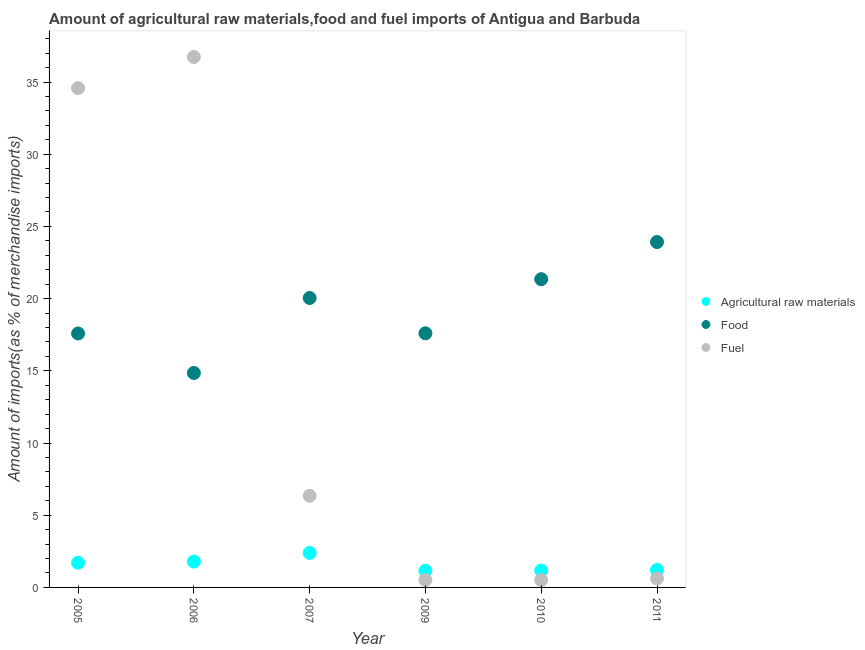How many different coloured dotlines are there?
Ensure brevity in your answer.  3. Is the number of dotlines equal to the number of legend labels?
Make the answer very short. Yes. What is the percentage of raw materials imports in 2006?
Offer a very short reply. 1.79. Across all years, what is the maximum percentage of raw materials imports?
Keep it short and to the point. 2.39. Across all years, what is the minimum percentage of fuel imports?
Your answer should be compact. 0.51. What is the total percentage of food imports in the graph?
Provide a succinct answer. 115.35. What is the difference between the percentage of food imports in 2007 and that in 2010?
Your answer should be very brief. -1.3. What is the difference between the percentage of raw materials imports in 2007 and the percentage of fuel imports in 2010?
Provide a succinct answer. 1.88. What is the average percentage of food imports per year?
Make the answer very short. 19.22. In the year 2005, what is the difference between the percentage of food imports and percentage of fuel imports?
Your answer should be compact. -16.99. In how many years, is the percentage of fuel imports greater than 28 %?
Give a very brief answer. 2. What is the ratio of the percentage of raw materials imports in 2005 to that in 2009?
Make the answer very short. 1.49. Is the percentage of fuel imports in 2010 less than that in 2011?
Provide a short and direct response. Yes. Is the difference between the percentage of raw materials imports in 2006 and 2007 greater than the difference between the percentage of fuel imports in 2006 and 2007?
Provide a succinct answer. No. What is the difference between the highest and the second highest percentage of food imports?
Provide a short and direct response. 2.57. What is the difference between the highest and the lowest percentage of fuel imports?
Make the answer very short. 36.22. In how many years, is the percentage of fuel imports greater than the average percentage of fuel imports taken over all years?
Your answer should be compact. 2. Is it the case that in every year, the sum of the percentage of raw materials imports and percentage of food imports is greater than the percentage of fuel imports?
Your answer should be very brief. No. Does the percentage of raw materials imports monotonically increase over the years?
Your answer should be compact. No. Is the percentage of raw materials imports strictly greater than the percentage of fuel imports over the years?
Keep it short and to the point. No. Is the percentage of raw materials imports strictly less than the percentage of fuel imports over the years?
Give a very brief answer. No. How many years are there in the graph?
Ensure brevity in your answer.  6. What is the difference between two consecutive major ticks on the Y-axis?
Offer a terse response. 5. Are the values on the major ticks of Y-axis written in scientific E-notation?
Provide a succinct answer. No. Does the graph contain grids?
Ensure brevity in your answer.  No. Where does the legend appear in the graph?
Ensure brevity in your answer.  Center right. How many legend labels are there?
Ensure brevity in your answer.  3. How are the legend labels stacked?
Ensure brevity in your answer.  Vertical. What is the title of the graph?
Provide a succinct answer. Amount of agricultural raw materials,food and fuel imports of Antigua and Barbuda. Does "Fuel" appear as one of the legend labels in the graph?
Ensure brevity in your answer.  Yes. What is the label or title of the Y-axis?
Keep it short and to the point. Amount of imports(as % of merchandise imports). What is the Amount of imports(as % of merchandise imports) of Agricultural raw materials in 2005?
Offer a terse response. 1.71. What is the Amount of imports(as % of merchandise imports) in Food in 2005?
Keep it short and to the point. 17.59. What is the Amount of imports(as % of merchandise imports) of Fuel in 2005?
Offer a very short reply. 34.58. What is the Amount of imports(as % of merchandise imports) in Agricultural raw materials in 2006?
Provide a short and direct response. 1.79. What is the Amount of imports(as % of merchandise imports) in Food in 2006?
Ensure brevity in your answer.  14.85. What is the Amount of imports(as % of merchandise imports) in Fuel in 2006?
Provide a succinct answer. 36.73. What is the Amount of imports(as % of merchandise imports) in Agricultural raw materials in 2007?
Your response must be concise. 2.39. What is the Amount of imports(as % of merchandise imports) of Food in 2007?
Give a very brief answer. 20.04. What is the Amount of imports(as % of merchandise imports) of Fuel in 2007?
Give a very brief answer. 6.35. What is the Amount of imports(as % of merchandise imports) of Agricultural raw materials in 2009?
Offer a very short reply. 1.15. What is the Amount of imports(as % of merchandise imports) of Food in 2009?
Offer a very short reply. 17.6. What is the Amount of imports(as % of merchandise imports) in Fuel in 2009?
Your answer should be very brief. 0.52. What is the Amount of imports(as % of merchandise imports) in Agricultural raw materials in 2010?
Your answer should be very brief. 1.17. What is the Amount of imports(as % of merchandise imports) of Food in 2010?
Provide a succinct answer. 21.35. What is the Amount of imports(as % of merchandise imports) of Fuel in 2010?
Your answer should be very brief. 0.51. What is the Amount of imports(as % of merchandise imports) in Agricultural raw materials in 2011?
Your response must be concise. 1.21. What is the Amount of imports(as % of merchandise imports) in Food in 2011?
Provide a succinct answer. 23.92. What is the Amount of imports(as % of merchandise imports) of Fuel in 2011?
Provide a succinct answer. 0.62. Across all years, what is the maximum Amount of imports(as % of merchandise imports) of Agricultural raw materials?
Your answer should be compact. 2.39. Across all years, what is the maximum Amount of imports(as % of merchandise imports) in Food?
Keep it short and to the point. 23.92. Across all years, what is the maximum Amount of imports(as % of merchandise imports) in Fuel?
Provide a succinct answer. 36.73. Across all years, what is the minimum Amount of imports(as % of merchandise imports) in Agricultural raw materials?
Your response must be concise. 1.15. Across all years, what is the minimum Amount of imports(as % of merchandise imports) of Food?
Ensure brevity in your answer.  14.85. Across all years, what is the minimum Amount of imports(as % of merchandise imports) in Fuel?
Provide a succinct answer. 0.51. What is the total Amount of imports(as % of merchandise imports) of Agricultural raw materials in the graph?
Provide a succinct answer. 9.42. What is the total Amount of imports(as % of merchandise imports) of Food in the graph?
Ensure brevity in your answer.  115.35. What is the total Amount of imports(as % of merchandise imports) in Fuel in the graph?
Your response must be concise. 79.31. What is the difference between the Amount of imports(as % of merchandise imports) in Agricultural raw materials in 2005 and that in 2006?
Give a very brief answer. -0.08. What is the difference between the Amount of imports(as % of merchandise imports) in Food in 2005 and that in 2006?
Provide a succinct answer. 2.74. What is the difference between the Amount of imports(as % of merchandise imports) in Fuel in 2005 and that in 2006?
Offer a very short reply. -2.16. What is the difference between the Amount of imports(as % of merchandise imports) in Agricultural raw materials in 2005 and that in 2007?
Your answer should be very brief. -0.68. What is the difference between the Amount of imports(as % of merchandise imports) of Food in 2005 and that in 2007?
Give a very brief answer. -2.46. What is the difference between the Amount of imports(as % of merchandise imports) of Fuel in 2005 and that in 2007?
Ensure brevity in your answer.  28.23. What is the difference between the Amount of imports(as % of merchandise imports) in Agricultural raw materials in 2005 and that in 2009?
Provide a succinct answer. 0.56. What is the difference between the Amount of imports(as % of merchandise imports) of Food in 2005 and that in 2009?
Offer a terse response. -0.01. What is the difference between the Amount of imports(as % of merchandise imports) in Fuel in 2005 and that in 2009?
Give a very brief answer. 34.06. What is the difference between the Amount of imports(as % of merchandise imports) in Agricultural raw materials in 2005 and that in 2010?
Give a very brief answer. 0.54. What is the difference between the Amount of imports(as % of merchandise imports) in Food in 2005 and that in 2010?
Provide a short and direct response. -3.76. What is the difference between the Amount of imports(as % of merchandise imports) in Fuel in 2005 and that in 2010?
Provide a succinct answer. 34.06. What is the difference between the Amount of imports(as % of merchandise imports) of Agricultural raw materials in 2005 and that in 2011?
Your answer should be very brief. 0.5. What is the difference between the Amount of imports(as % of merchandise imports) in Food in 2005 and that in 2011?
Provide a short and direct response. -6.33. What is the difference between the Amount of imports(as % of merchandise imports) of Fuel in 2005 and that in 2011?
Offer a terse response. 33.95. What is the difference between the Amount of imports(as % of merchandise imports) of Agricultural raw materials in 2006 and that in 2007?
Give a very brief answer. -0.6. What is the difference between the Amount of imports(as % of merchandise imports) of Food in 2006 and that in 2007?
Provide a succinct answer. -5.19. What is the difference between the Amount of imports(as % of merchandise imports) of Fuel in 2006 and that in 2007?
Offer a terse response. 30.39. What is the difference between the Amount of imports(as % of merchandise imports) in Agricultural raw materials in 2006 and that in 2009?
Provide a short and direct response. 0.64. What is the difference between the Amount of imports(as % of merchandise imports) of Food in 2006 and that in 2009?
Ensure brevity in your answer.  -2.75. What is the difference between the Amount of imports(as % of merchandise imports) of Fuel in 2006 and that in 2009?
Provide a succinct answer. 36.22. What is the difference between the Amount of imports(as % of merchandise imports) of Agricultural raw materials in 2006 and that in 2010?
Your answer should be compact. 0.62. What is the difference between the Amount of imports(as % of merchandise imports) of Food in 2006 and that in 2010?
Offer a very short reply. -6.49. What is the difference between the Amount of imports(as % of merchandise imports) in Fuel in 2006 and that in 2010?
Offer a terse response. 36.22. What is the difference between the Amount of imports(as % of merchandise imports) in Agricultural raw materials in 2006 and that in 2011?
Make the answer very short. 0.58. What is the difference between the Amount of imports(as % of merchandise imports) of Food in 2006 and that in 2011?
Your answer should be compact. -9.07. What is the difference between the Amount of imports(as % of merchandise imports) of Fuel in 2006 and that in 2011?
Offer a very short reply. 36.11. What is the difference between the Amount of imports(as % of merchandise imports) in Agricultural raw materials in 2007 and that in 2009?
Your answer should be very brief. 1.24. What is the difference between the Amount of imports(as % of merchandise imports) of Food in 2007 and that in 2009?
Offer a very short reply. 2.44. What is the difference between the Amount of imports(as % of merchandise imports) in Fuel in 2007 and that in 2009?
Make the answer very short. 5.83. What is the difference between the Amount of imports(as % of merchandise imports) in Agricultural raw materials in 2007 and that in 2010?
Keep it short and to the point. 1.22. What is the difference between the Amount of imports(as % of merchandise imports) of Food in 2007 and that in 2010?
Give a very brief answer. -1.3. What is the difference between the Amount of imports(as % of merchandise imports) in Fuel in 2007 and that in 2010?
Provide a short and direct response. 5.84. What is the difference between the Amount of imports(as % of merchandise imports) in Agricultural raw materials in 2007 and that in 2011?
Your answer should be compact. 1.18. What is the difference between the Amount of imports(as % of merchandise imports) of Food in 2007 and that in 2011?
Your answer should be compact. -3.87. What is the difference between the Amount of imports(as % of merchandise imports) in Fuel in 2007 and that in 2011?
Keep it short and to the point. 5.72. What is the difference between the Amount of imports(as % of merchandise imports) in Agricultural raw materials in 2009 and that in 2010?
Your response must be concise. -0.02. What is the difference between the Amount of imports(as % of merchandise imports) in Food in 2009 and that in 2010?
Ensure brevity in your answer.  -3.75. What is the difference between the Amount of imports(as % of merchandise imports) of Fuel in 2009 and that in 2010?
Provide a succinct answer. 0.01. What is the difference between the Amount of imports(as % of merchandise imports) in Agricultural raw materials in 2009 and that in 2011?
Offer a very short reply. -0.06. What is the difference between the Amount of imports(as % of merchandise imports) in Food in 2009 and that in 2011?
Your answer should be very brief. -6.32. What is the difference between the Amount of imports(as % of merchandise imports) in Fuel in 2009 and that in 2011?
Give a very brief answer. -0.1. What is the difference between the Amount of imports(as % of merchandise imports) of Agricultural raw materials in 2010 and that in 2011?
Make the answer very short. -0.04. What is the difference between the Amount of imports(as % of merchandise imports) in Food in 2010 and that in 2011?
Give a very brief answer. -2.57. What is the difference between the Amount of imports(as % of merchandise imports) in Fuel in 2010 and that in 2011?
Provide a succinct answer. -0.11. What is the difference between the Amount of imports(as % of merchandise imports) of Agricultural raw materials in 2005 and the Amount of imports(as % of merchandise imports) of Food in 2006?
Your answer should be very brief. -13.14. What is the difference between the Amount of imports(as % of merchandise imports) in Agricultural raw materials in 2005 and the Amount of imports(as % of merchandise imports) in Fuel in 2006?
Offer a terse response. -35.02. What is the difference between the Amount of imports(as % of merchandise imports) of Food in 2005 and the Amount of imports(as % of merchandise imports) of Fuel in 2006?
Your response must be concise. -19.15. What is the difference between the Amount of imports(as % of merchandise imports) in Agricultural raw materials in 2005 and the Amount of imports(as % of merchandise imports) in Food in 2007?
Keep it short and to the point. -18.33. What is the difference between the Amount of imports(as % of merchandise imports) in Agricultural raw materials in 2005 and the Amount of imports(as % of merchandise imports) in Fuel in 2007?
Give a very brief answer. -4.64. What is the difference between the Amount of imports(as % of merchandise imports) in Food in 2005 and the Amount of imports(as % of merchandise imports) in Fuel in 2007?
Keep it short and to the point. 11.24. What is the difference between the Amount of imports(as % of merchandise imports) of Agricultural raw materials in 2005 and the Amount of imports(as % of merchandise imports) of Food in 2009?
Your answer should be compact. -15.89. What is the difference between the Amount of imports(as % of merchandise imports) in Agricultural raw materials in 2005 and the Amount of imports(as % of merchandise imports) in Fuel in 2009?
Give a very brief answer. 1.19. What is the difference between the Amount of imports(as % of merchandise imports) of Food in 2005 and the Amount of imports(as % of merchandise imports) of Fuel in 2009?
Offer a very short reply. 17.07. What is the difference between the Amount of imports(as % of merchandise imports) in Agricultural raw materials in 2005 and the Amount of imports(as % of merchandise imports) in Food in 2010?
Keep it short and to the point. -19.64. What is the difference between the Amount of imports(as % of merchandise imports) of Agricultural raw materials in 2005 and the Amount of imports(as % of merchandise imports) of Fuel in 2010?
Your answer should be compact. 1.2. What is the difference between the Amount of imports(as % of merchandise imports) in Food in 2005 and the Amount of imports(as % of merchandise imports) in Fuel in 2010?
Offer a terse response. 17.08. What is the difference between the Amount of imports(as % of merchandise imports) in Agricultural raw materials in 2005 and the Amount of imports(as % of merchandise imports) in Food in 2011?
Keep it short and to the point. -22.21. What is the difference between the Amount of imports(as % of merchandise imports) in Agricultural raw materials in 2005 and the Amount of imports(as % of merchandise imports) in Fuel in 2011?
Make the answer very short. 1.09. What is the difference between the Amount of imports(as % of merchandise imports) in Food in 2005 and the Amount of imports(as % of merchandise imports) in Fuel in 2011?
Provide a succinct answer. 16.97. What is the difference between the Amount of imports(as % of merchandise imports) in Agricultural raw materials in 2006 and the Amount of imports(as % of merchandise imports) in Food in 2007?
Offer a terse response. -18.25. What is the difference between the Amount of imports(as % of merchandise imports) in Agricultural raw materials in 2006 and the Amount of imports(as % of merchandise imports) in Fuel in 2007?
Provide a succinct answer. -4.55. What is the difference between the Amount of imports(as % of merchandise imports) in Food in 2006 and the Amount of imports(as % of merchandise imports) in Fuel in 2007?
Give a very brief answer. 8.51. What is the difference between the Amount of imports(as % of merchandise imports) of Agricultural raw materials in 2006 and the Amount of imports(as % of merchandise imports) of Food in 2009?
Ensure brevity in your answer.  -15.81. What is the difference between the Amount of imports(as % of merchandise imports) of Agricultural raw materials in 2006 and the Amount of imports(as % of merchandise imports) of Fuel in 2009?
Offer a very short reply. 1.27. What is the difference between the Amount of imports(as % of merchandise imports) of Food in 2006 and the Amount of imports(as % of merchandise imports) of Fuel in 2009?
Provide a short and direct response. 14.33. What is the difference between the Amount of imports(as % of merchandise imports) in Agricultural raw materials in 2006 and the Amount of imports(as % of merchandise imports) in Food in 2010?
Ensure brevity in your answer.  -19.55. What is the difference between the Amount of imports(as % of merchandise imports) in Agricultural raw materials in 2006 and the Amount of imports(as % of merchandise imports) in Fuel in 2010?
Give a very brief answer. 1.28. What is the difference between the Amount of imports(as % of merchandise imports) in Food in 2006 and the Amount of imports(as % of merchandise imports) in Fuel in 2010?
Make the answer very short. 14.34. What is the difference between the Amount of imports(as % of merchandise imports) in Agricultural raw materials in 2006 and the Amount of imports(as % of merchandise imports) in Food in 2011?
Make the answer very short. -22.13. What is the difference between the Amount of imports(as % of merchandise imports) of Agricultural raw materials in 2006 and the Amount of imports(as % of merchandise imports) of Fuel in 2011?
Provide a short and direct response. 1.17. What is the difference between the Amount of imports(as % of merchandise imports) in Food in 2006 and the Amount of imports(as % of merchandise imports) in Fuel in 2011?
Ensure brevity in your answer.  14.23. What is the difference between the Amount of imports(as % of merchandise imports) in Agricultural raw materials in 2007 and the Amount of imports(as % of merchandise imports) in Food in 2009?
Ensure brevity in your answer.  -15.21. What is the difference between the Amount of imports(as % of merchandise imports) in Agricultural raw materials in 2007 and the Amount of imports(as % of merchandise imports) in Fuel in 2009?
Offer a very short reply. 1.87. What is the difference between the Amount of imports(as % of merchandise imports) in Food in 2007 and the Amount of imports(as % of merchandise imports) in Fuel in 2009?
Make the answer very short. 19.53. What is the difference between the Amount of imports(as % of merchandise imports) of Agricultural raw materials in 2007 and the Amount of imports(as % of merchandise imports) of Food in 2010?
Your answer should be very brief. -18.96. What is the difference between the Amount of imports(as % of merchandise imports) in Agricultural raw materials in 2007 and the Amount of imports(as % of merchandise imports) in Fuel in 2010?
Offer a very short reply. 1.88. What is the difference between the Amount of imports(as % of merchandise imports) in Food in 2007 and the Amount of imports(as % of merchandise imports) in Fuel in 2010?
Offer a terse response. 19.53. What is the difference between the Amount of imports(as % of merchandise imports) in Agricultural raw materials in 2007 and the Amount of imports(as % of merchandise imports) in Food in 2011?
Offer a very short reply. -21.53. What is the difference between the Amount of imports(as % of merchandise imports) in Agricultural raw materials in 2007 and the Amount of imports(as % of merchandise imports) in Fuel in 2011?
Provide a short and direct response. 1.77. What is the difference between the Amount of imports(as % of merchandise imports) in Food in 2007 and the Amount of imports(as % of merchandise imports) in Fuel in 2011?
Ensure brevity in your answer.  19.42. What is the difference between the Amount of imports(as % of merchandise imports) of Agricultural raw materials in 2009 and the Amount of imports(as % of merchandise imports) of Food in 2010?
Provide a succinct answer. -20.19. What is the difference between the Amount of imports(as % of merchandise imports) of Agricultural raw materials in 2009 and the Amount of imports(as % of merchandise imports) of Fuel in 2010?
Keep it short and to the point. 0.64. What is the difference between the Amount of imports(as % of merchandise imports) of Food in 2009 and the Amount of imports(as % of merchandise imports) of Fuel in 2010?
Your answer should be compact. 17.09. What is the difference between the Amount of imports(as % of merchandise imports) in Agricultural raw materials in 2009 and the Amount of imports(as % of merchandise imports) in Food in 2011?
Offer a terse response. -22.77. What is the difference between the Amount of imports(as % of merchandise imports) in Agricultural raw materials in 2009 and the Amount of imports(as % of merchandise imports) in Fuel in 2011?
Your response must be concise. 0.53. What is the difference between the Amount of imports(as % of merchandise imports) of Food in 2009 and the Amount of imports(as % of merchandise imports) of Fuel in 2011?
Your answer should be very brief. 16.98. What is the difference between the Amount of imports(as % of merchandise imports) of Agricultural raw materials in 2010 and the Amount of imports(as % of merchandise imports) of Food in 2011?
Keep it short and to the point. -22.75. What is the difference between the Amount of imports(as % of merchandise imports) in Agricultural raw materials in 2010 and the Amount of imports(as % of merchandise imports) in Fuel in 2011?
Your answer should be very brief. 0.55. What is the difference between the Amount of imports(as % of merchandise imports) of Food in 2010 and the Amount of imports(as % of merchandise imports) of Fuel in 2011?
Provide a succinct answer. 20.73. What is the average Amount of imports(as % of merchandise imports) in Agricultural raw materials per year?
Provide a succinct answer. 1.57. What is the average Amount of imports(as % of merchandise imports) in Food per year?
Your answer should be very brief. 19.22. What is the average Amount of imports(as % of merchandise imports) of Fuel per year?
Your answer should be compact. 13.22. In the year 2005, what is the difference between the Amount of imports(as % of merchandise imports) in Agricultural raw materials and Amount of imports(as % of merchandise imports) in Food?
Provide a succinct answer. -15.88. In the year 2005, what is the difference between the Amount of imports(as % of merchandise imports) in Agricultural raw materials and Amount of imports(as % of merchandise imports) in Fuel?
Ensure brevity in your answer.  -32.86. In the year 2005, what is the difference between the Amount of imports(as % of merchandise imports) of Food and Amount of imports(as % of merchandise imports) of Fuel?
Ensure brevity in your answer.  -16.99. In the year 2006, what is the difference between the Amount of imports(as % of merchandise imports) of Agricultural raw materials and Amount of imports(as % of merchandise imports) of Food?
Provide a succinct answer. -13.06. In the year 2006, what is the difference between the Amount of imports(as % of merchandise imports) of Agricultural raw materials and Amount of imports(as % of merchandise imports) of Fuel?
Give a very brief answer. -34.94. In the year 2006, what is the difference between the Amount of imports(as % of merchandise imports) of Food and Amount of imports(as % of merchandise imports) of Fuel?
Offer a very short reply. -21.88. In the year 2007, what is the difference between the Amount of imports(as % of merchandise imports) in Agricultural raw materials and Amount of imports(as % of merchandise imports) in Food?
Your answer should be very brief. -17.66. In the year 2007, what is the difference between the Amount of imports(as % of merchandise imports) in Agricultural raw materials and Amount of imports(as % of merchandise imports) in Fuel?
Offer a terse response. -3.96. In the year 2007, what is the difference between the Amount of imports(as % of merchandise imports) in Food and Amount of imports(as % of merchandise imports) in Fuel?
Ensure brevity in your answer.  13.7. In the year 2009, what is the difference between the Amount of imports(as % of merchandise imports) of Agricultural raw materials and Amount of imports(as % of merchandise imports) of Food?
Provide a short and direct response. -16.45. In the year 2009, what is the difference between the Amount of imports(as % of merchandise imports) in Agricultural raw materials and Amount of imports(as % of merchandise imports) in Fuel?
Provide a succinct answer. 0.63. In the year 2009, what is the difference between the Amount of imports(as % of merchandise imports) of Food and Amount of imports(as % of merchandise imports) of Fuel?
Keep it short and to the point. 17.08. In the year 2010, what is the difference between the Amount of imports(as % of merchandise imports) of Agricultural raw materials and Amount of imports(as % of merchandise imports) of Food?
Ensure brevity in your answer.  -20.18. In the year 2010, what is the difference between the Amount of imports(as % of merchandise imports) of Agricultural raw materials and Amount of imports(as % of merchandise imports) of Fuel?
Provide a succinct answer. 0.66. In the year 2010, what is the difference between the Amount of imports(as % of merchandise imports) in Food and Amount of imports(as % of merchandise imports) in Fuel?
Give a very brief answer. 20.84. In the year 2011, what is the difference between the Amount of imports(as % of merchandise imports) in Agricultural raw materials and Amount of imports(as % of merchandise imports) in Food?
Make the answer very short. -22.71. In the year 2011, what is the difference between the Amount of imports(as % of merchandise imports) of Agricultural raw materials and Amount of imports(as % of merchandise imports) of Fuel?
Provide a short and direct response. 0.59. In the year 2011, what is the difference between the Amount of imports(as % of merchandise imports) in Food and Amount of imports(as % of merchandise imports) in Fuel?
Provide a succinct answer. 23.3. What is the ratio of the Amount of imports(as % of merchandise imports) of Agricultural raw materials in 2005 to that in 2006?
Keep it short and to the point. 0.95. What is the ratio of the Amount of imports(as % of merchandise imports) of Food in 2005 to that in 2006?
Give a very brief answer. 1.18. What is the ratio of the Amount of imports(as % of merchandise imports) in Fuel in 2005 to that in 2006?
Your answer should be compact. 0.94. What is the ratio of the Amount of imports(as % of merchandise imports) in Agricultural raw materials in 2005 to that in 2007?
Keep it short and to the point. 0.72. What is the ratio of the Amount of imports(as % of merchandise imports) of Food in 2005 to that in 2007?
Keep it short and to the point. 0.88. What is the ratio of the Amount of imports(as % of merchandise imports) in Fuel in 2005 to that in 2007?
Provide a succinct answer. 5.45. What is the ratio of the Amount of imports(as % of merchandise imports) of Agricultural raw materials in 2005 to that in 2009?
Provide a succinct answer. 1.49. What is the ratio of the Amount of imports(as % of merchandise imports) of Food in 2005 to that in 2009?
Your answer should be compact. 1. What is the ratio of the Amount of imports(as % of merchandise imports) in Fuel in 2005 to that in 2009?
Offer a very short reply. 66.65. What is the ratio of the Amount of imports(as % of merchandise imports) in Agricultural raw materials in 2005 to that in 2010?
Your answer should be compact. 1.46. What is the ratio of the Amount of imports(as % of merchandise imports) of Food in 2005 to that in 2010?
Make the answer very short. 0.82. What is the ratio of the Amount of imports(as % of merchandise imports) of Fuel in 2005 to that in 2010?
Offer a very short reply. 67.68. What is the ratio of the Amount of imports(as % of merchandise imports) of Agricultural raw materials in 2005 to that in 2011?
Make the answer very short. 1.41. What is the ratio of the Amount of imports(as % of merchandise imports) in Food in 2005 to that in 2011?
Your response must be concise. 0.74. What is the ratio of the Amount of imports(as % of merchandise imports) of Fuel in 2005 to that in 2011?
Your answer should be very brief. 55.67. What is the ratio of the Amount of imports(as % of merchandise imports) in Agricultural raw materials in 2006 to that in 2007?
Provide a succinct answer. 0.75. What is the ratio of the Amount of imports(as % of merchandise imports) in Food in 2006 to that in 2007?
Offer a terse response. 0.74. What is the ratio of the Amount of imports(as % of merchandise imports) in Fuel in 2006 to that in 2007?
Keep it short and to the point. 5.79. What is the ratio of the Amount of imports(as % of merchandise imports) of Agricultural raw materials in 2006 to that in 2009?
Provide a succinct answer. 1.56. What is the ratio of the Amount of imports(as % of merchandise imports) of Food in 2006 to that in 2009?
Offer a very short reply. 0.84. What is the ratio of the Amount of imports(as % of merchandise imports) of Fuel in 2006 to that in 2009?
Ensure brevity in your answer.  70.82. What is the ratio of the Amount of imports(as % of merchandise imports) in Agricultural raw materials in 2006 to that in 2010?
Your response must be concise. 1.53. What is the ratio of the Amount of imports(as % of merchandise imports) of Food in 2006 to that in 2010?
Offer a terse response. 0.7. What is the ratio of the Amount of imports(as % of merchandise imports) of Fuel in 2006 to that in 2010?
Offer a very short reply. 71.91. What is the ratio of the Amount of imports(as % of merchandise imports) in Agricultural raw materials in 2006 to that in 2011?
Provide a succinct answer. 1.48. What is the ratio of the Amount of imports(as % of merchandise imports) of Food in 2006 to that in 2011?
Offer a very short reply. 0.62. What is the ratio of the Amount of imports(as % of merchandise imports) of Fuel in 2006 to that in 2011?
Ensure brevity in your answer.  59.15. What is the ratio of the Amount of imports(as % of merchandise imports) in Agricultural raw materials in 2007 to that in 2009?
Give a very brief answer. 2.07. What is the ratio of the Amount of imports(as % of merchandise imports) in Food in 2007 to that in 2009?
Your answer should be compact. 1.14. What is the ratio of the Amount of imports(as % of merchandise imports) in Fuel in 2007 to that in 2009?
Provide a short and direct response. 12.23. What is the ratio of the Amount of imports(as % of merchandise imports) in Agricultural raw materials in 2007 to that in 2010?
Your answer should be compact. 2.05. What is the ratio of the Amount of imports(as % of merchandise imports) of Food in 2007 to that in 2010?
Your answer should be very brief. 0.94. What is the ratio of the Amount of imports(as % of merchandise imports) in Fuel in 2007 to that in 2010?
Your response must be concise. 12.42. What is the ratio of the Amount of imports(as % of merchandise imports) in Agricultural raw materials in 2007 to that in 2011?
Your response must be concise. 1.97. What is the ratio of the Amount of imports(as % of merchandise imports) in Food in 2007 to that in 2011?
Your response must be concise. 0.84. What is the ratio of the Amount of imports(as % of merchandise imports) in Fuel in 2007 to that in 2011?
Offer a terse response. 10.22. What is the ratio of the Amount of imports(as % of merchandise imports) in Agricultural raw materials in 2009 to that in 2010?
Your response must be concise. 0.99. What is the ratio of the Amount of imports(as % of merchandise imports) of Food in 2009 to that in 2010?
Ensure brevity in your answer.  0.82. What is the ratio of the Amount of imports(as % of merchandise imports) in Fuel in 2009 to that in 2010?
Keep it short and to the point. 1.02. What is the ratio of the Amount of imports(as % of merchandise imports) in Agricultural raw materials in 2009 to that in 2011?
Your answer should be very brief. 0.95. What is the ratio of the Amount of imports(as % of merchandise imports) of Food in 2009 to that in 2011?
Ensure brevity in your answer.  0.74. What is the ratio of the Amount of imports(as % of merchandise imports) of Fuel in 2009 to that in 2011?
Offer a very short reply. 0.84. What is the ratio of the Amount of imports(as % of merchandise imports) in Agricultural raw materials in 2010 to that in 2011?
Make the answer very short. 0.97. What is the ratio of the Amount of imports(as % of merchandise imports) of Food in 2010 to that in 2011?
Offer a terse response. 0.89. What is the ratio of the Amount of imports(as % of merchandise imports) in Fuel in 2010 to that in 2011?
Make the answer very short. 0.82. What is the difference between the highest and the second highest Amount of imports(as % of merchandise imports) of Agricultural raw materials?
Provide a short and direct response. 0.6. What is the difference between the highest and the second highest Amount of imports(as % of merchandise imports) of Food?
Ensure brevity in your answer.  2.57. What is the difference between the highest and the second highest Amount of imports(as % of merchandise imports) of Fuel?
Your response must be concise. 2.16. What is the difference between the highest and the lowest Amount of imports(as % of merchandise imports) of Agricultural raw materials?
Offer a terse response. 1.24. What is the difference between the highest and the lowest Amount of imports(as % of merchandise imports) in Food?
Provide a succinct answer. 9.07. What is the difference between the highest and the lowest Amount of imports(as % of merchandise imports) in Fuel?
Make the answer very short. 36.22. 